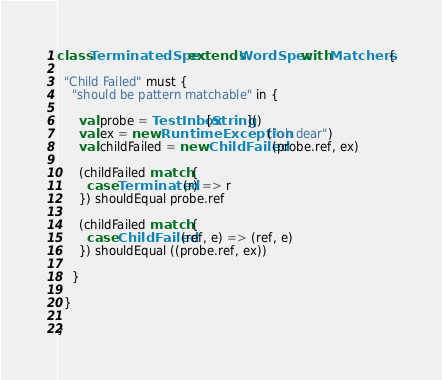Convert code to text. <code><loc_0><loc_0><loc_500><loc_500><_Scala_>class TerminatedSpec extends WordSpec with Matchers {

  "Child Failed" must {
    "should be pattern matchable" in {

      val probe = TestInbox[String]()
      val ex = new RuntimeException("oh dear")
      val childFailed = new ChildFailed(probe.ref, ex)

      (childFailed match {
        case Terminated(r) => r
      }) shouldEqual probe.ref

      (childFailed match {
        case ChildFailed(ref, e) => (ref, e)
      }) shouldEqual ((probe.ref, ex))

    }

  }

}
</code> 